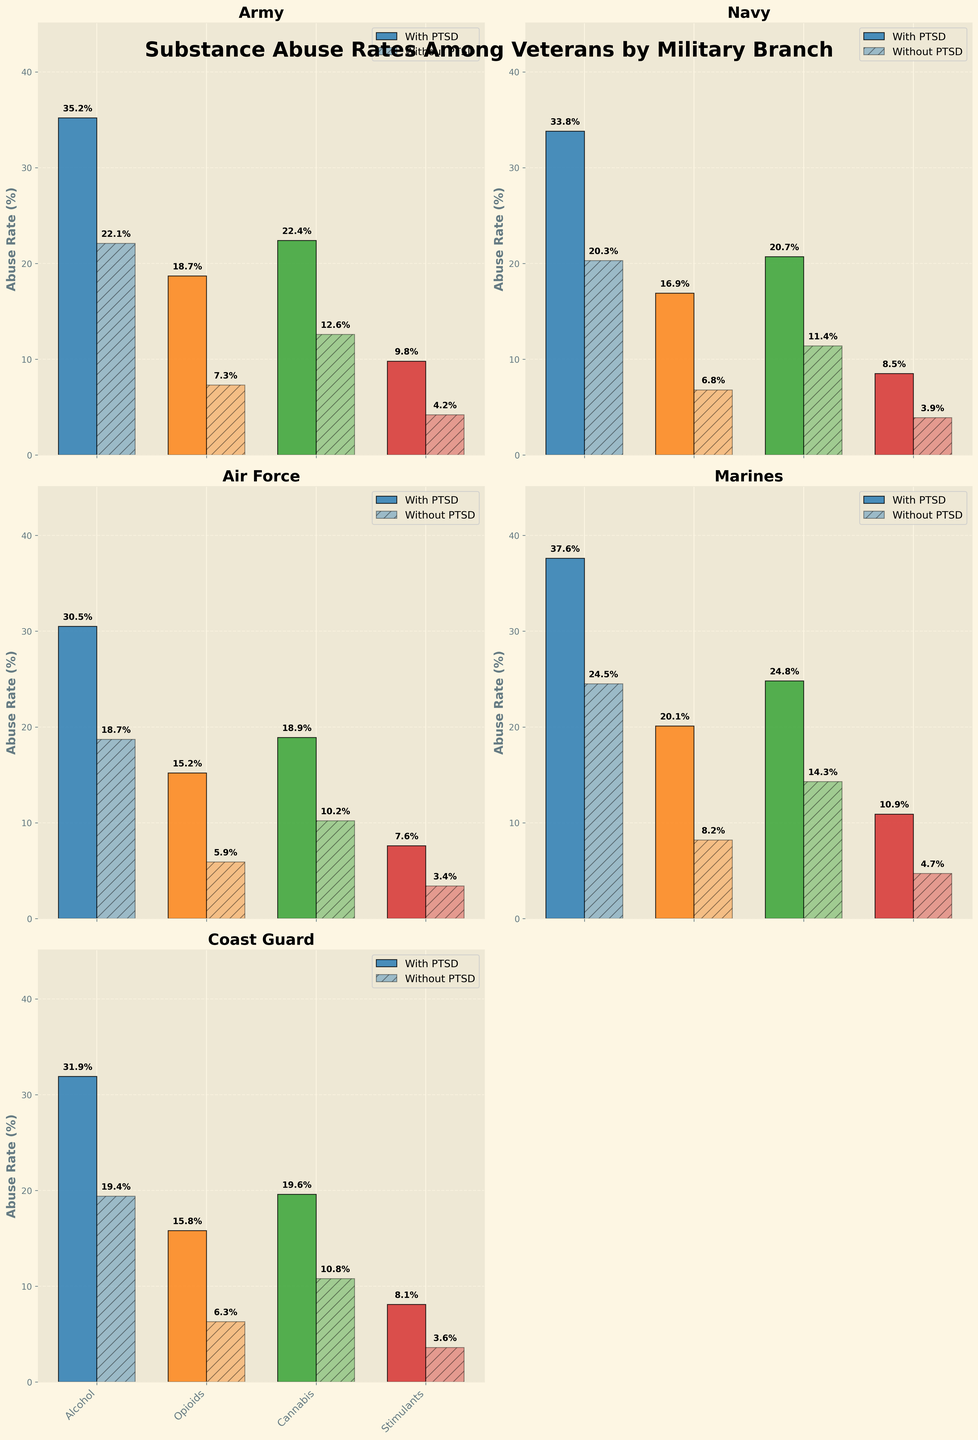What is the substance with the highest abuse rate among Army veterans with PTSD? By looking at the plot for the Army branch, we can observe the height of the bars representing the abuse rates of different substances. The tallest bar among Army veterans with PTSD represents Alcohol, with an abuse rate of 35.2%.
Answer: Alcohol Which branch has the highest abuse rate for Opioids among veterans with PTSD? To determine this, we compare the height of the bars representing Opioid abuse rates among veterans with PTSD across all military branches. The Marines branch has the highest Opioid abuse rate among veterans with PTSD, at 20.1%.
Answer: Marines Is the abuse rate of Cannabis higher in the Air Force or Navy, among those with PTSD? We need to compare the height of the Cannabis bars in the plots for the Air Force and Navy branches among veterans with PTSD. The abuse rate of Cannabis is higher in Navy veterans with PTSD (20.7%) than in Air Force veterans with PTSD (18.9%).
Answer: Navy What is the difference in the abuse rate of Stimulants between Marines with PTSD and without PTSD? In the plot for the Marines branch, observe the heights of the bars representing the Stimulant abuse rates. The abuse rate is 10.9% for those with PTSD and 4.7% for those without PTSD. The difference is 10.9% - 4.7% = 6.2%.
Answer: 6.2% Which substance has the smallest difference in abuse rates between veterans with and without PTSD in the Coast Guard branch? Compare the height differences between the bars representing the abuse rates for each substance among veterans with and without PTSD in the Coast Guard branch. The smallest difference is for Stimulants, with abuse rates of 8.1% (with PTSD) and 3.6% (without PTSD), resulting in a difference of 8.1% - 3.6% = 4.5%.
Answer: Stimulants Which branch has the lowest abuse rate of Alcohol among veterans without PTSD? By comparing the height of the Alcohol bars among veterans without PTSD across all branches, the Air Force has the lowest rate at 18.7%.
Answer: Air Force In which military branch is the difference in alcohol abuse rates between veterans with and without PTSD the largest? Evaluate the difference in the height of the Alcohol bars for veterans with and without PTSD in each branch. The Marines have the largest difference, with abuse rates of 37.6% (with PTSD) and 24.5% (without PTSD), resulting in a difference of 13.1%.
Answer: Marines Calculate the average abuse rate of Cannabis for veterans without PTSD across all branches. Sum the Cannabis abuse rates for veterans without PTSD across all branches and divide by the number of branches: (12.6 + 11.4 + 10.2 + 14.3 + 10.8) / 5 = 59.3 / 5 = 11.86%.
Answer: 11.86% For which substance is the abuse rate higher in the Army than in the Navy regardless of PTSD status? Compare the heights of the bars for each substance between the Army and Navy plots, considering both with PTSD and without PTSD. For Alcohol, with PTSD: Army (35.2%) > Navy (33.8%) and without PTSD: Army (22.1%) > Navy (20.3%).
Answer: Alcohol 